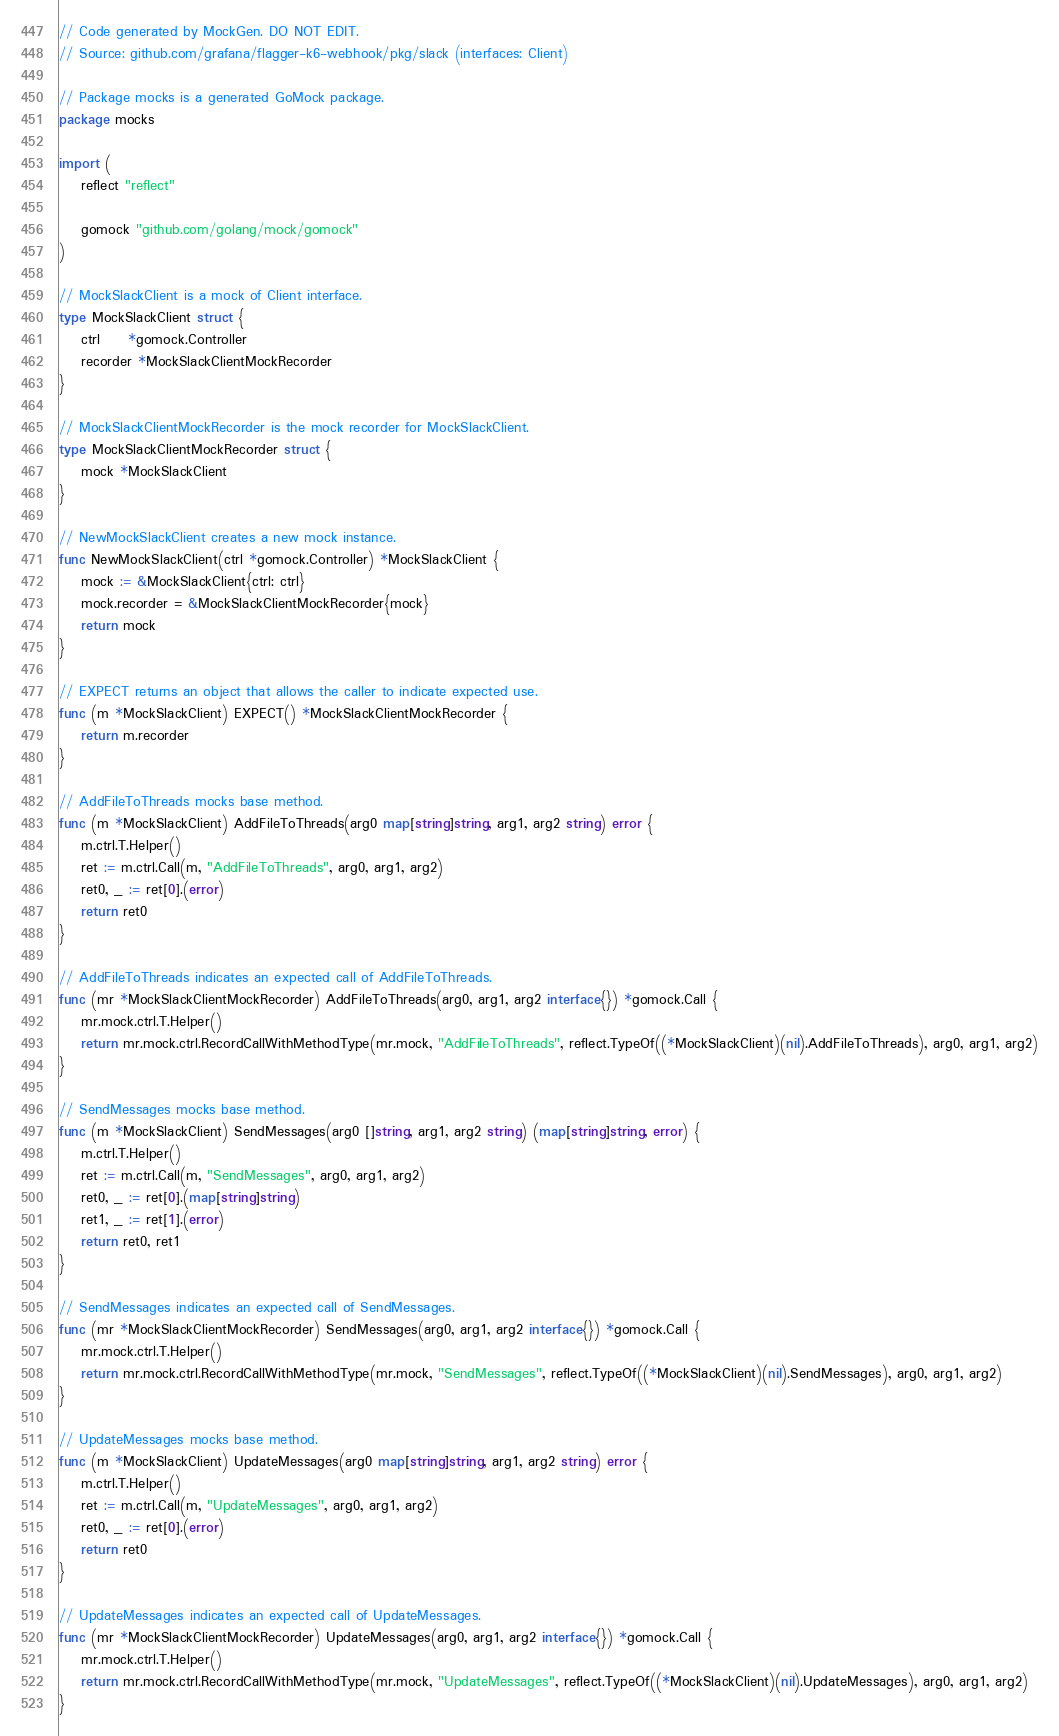<code> <loc_0><loc_0><loc_500><loc_500><_Go_>// Code generated by MockGen. DO NOT EDIT.
// Source: github.com/grafana/flagger-k6-webhook/pkg/slack (interfaces: Client)

// Package mocks is a generated GoMock package.
package mocks

import (
	reflect "reflect"

	gomock "github.com/golang/mock/gomock"
)

// MockSlackClient is a mock of Client interface.
type MockSlackClient struct {
	ctrl     *gomock.Controller
	recorder *MockSlackClientMockRecorder
}

// MockSlackClientMockRecorder is the mock recorder for MockSlackClient.
type MockSlackClientMockRecorder struct {
	mock *MockSlackClient
}

// NewMockSlackClient creates a new mock instance.
func NewMockSlackClient(ctrl *gomock.Controller) *MockSlackClient {
	mock := &MockSlackClient{ctrl: ctrl}
	mock.recorder = &MockSlackClientMockRecorder{mock}
	return mock
}

// EXPECT returns an object that allows the caller to indicate expected use.
func (m *MockSlackClient) EXPECT() *MockSlackClientMockRecorder {
	return m.recorder
}

// AddFileToThreads mocks base method.
func (m *MockSlackClient) AddFileToThreads(arg0 map[string]string, arg1, arg2 string) error {
	m.ctrl.T.Helper()
	ret := m.ctrl.Call(m, "AddFileToThreads", arg0, arg1, arg2)
	ret0, _ := ret[0].(error)
	return ret0
}

// AddFileToThreads indicates an expected call of AddFileToThreads.
func (mr *MockSlackClientMockRecorder) AddFileToThreads(arg0, arg1, arg2 interface{}) *gomock.Call {
	mr.mock.ctrl.T.Helper()
	return mr.mock.ctrl.RecordCallWithMethodType(mr.mock, "AddFileToThreads", reflect.TypeOf((*MockSlackClient)(nil).AddFileToThreads), arg0, arg1, arg2)
}

// SendMessages mocks base method.
func (m *MockSlackClient) SendMessages(arg0 []string, arg1, arg2 string) (map[string]string, error) {
	m.ctrl.T.Helper()
	ret := m.ctrl.Call(m, "SendMessages", arg0, arg1, arg2)
	ret0, _ := ret[0].(map[string]string)
	ret1, _ := ret[1].(error)
	return ret0, ret1
}

// SendMessages indicates an expected call of SendMessages.
func (mr *MockSlackClientMockRecorder) SendMessages(arg0, arg1, arg2 interface{}) *gomock.Call {
	mr.mock.ctrl.T.Helper()
	return mr.mock.ctrl.RecordCallWithMethodType(mr.mock, "SendMessages", reflect.TypeOf((*MockSlackClient)(nil).SendMessages), arg0, arg1, arg2)
}

// UpdateMessages mocks base method.
func (m *MockSlackClient) UpdateMessages(arg0 map[string]string, arg1, arg2 string) error {
	m.ctrl.T.Helper()
	ret := m.ctrl.Call(m, "UpdateMessages", arg0, arg1, arg2)
	ret0, _ := ret[0].(error)
	return ret0
}

// UpdateMessages indicates an expected call of UpdateMessages.
func (mr *MockSlackClientMockRecorder) UpdateMessages(arg0, arg1, arg2 interface{}) *gomock.Call {
	mr.mock.ctrl.T.Helper()
	return mr.mock.ctrl.RecordCallWithMethodType(mr.mock, "UpdateMessages", reflect.TypeOf((*MockSlackClient)(nil).UpdateMessages), arg0, arg1, arg2)
}
</code> 